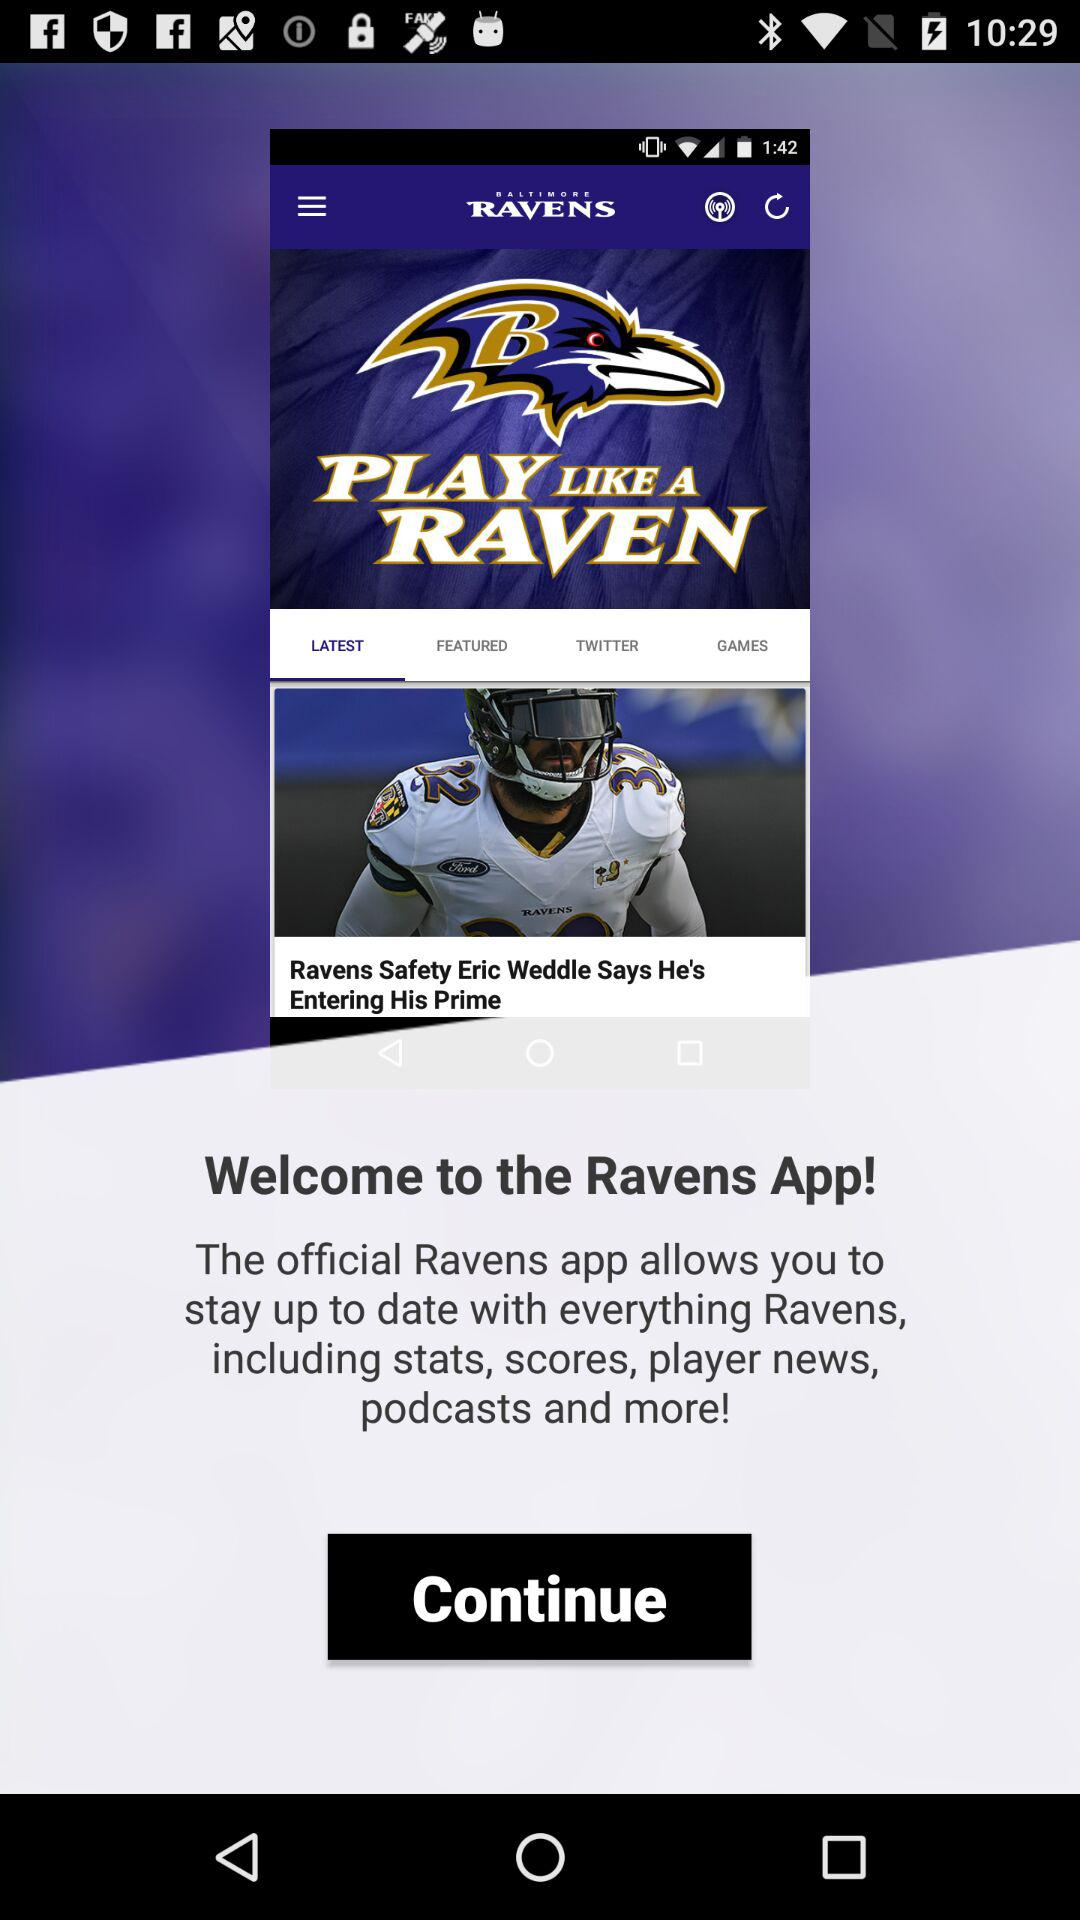What is the name of the application? The name of the application is "Baltimore Ravens Mobile". 